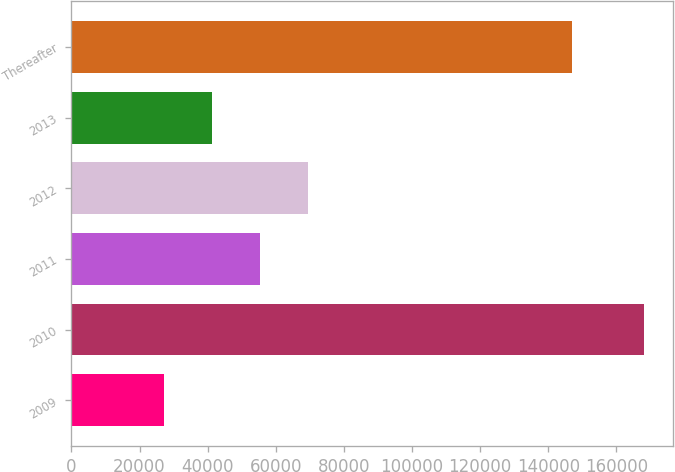Convert chart. <chart><loc_0><loc_0><loc_500><loc_500><bar_chart><fcel>2009<fcel>2010<fcel>2011<fcel>2012<fcel>2013<fcel>Thereafter<nl><fcel>27182<fcel>168163<fcel>55378.2<fcel>69476.3<fcel>41280.1<fcel>146930<nl></chart> 